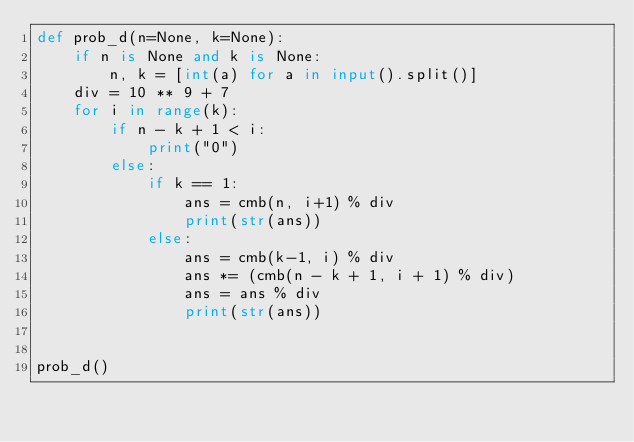<code> <loc_0><loc_0><loc_500><loc_500><_Python_>def prob_d(n=None, k=None):
    if n is None and k is None:
        n, k = [int(a) for a in input().split()]
    div = 10 ** 9 + 7
    for i in range(k):
        if n - k + 1 < i:
            print("0")
        else:
            if k == 1:
                ans = cmb(n, i+1) % div
                print(str(ans))
            else:
                ans = cmb(k-1, i) % div
                ans *= (cmb(n - k + 1, i + 1) % div)
                ans = ans % div
                print(str(ans))


prob_d()</code> 